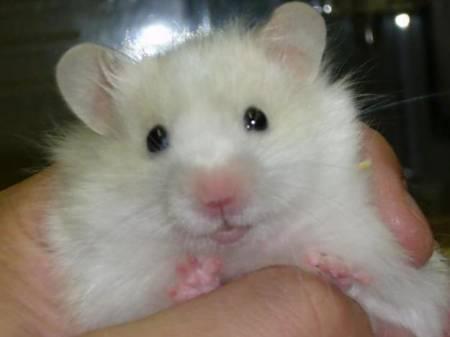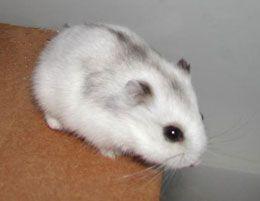The first image is the image on the left, the second image is the image on the right. Examine the images to the left and right. Is the description "An animal is eating something yellow." accurate? Answer yes or no. No. 